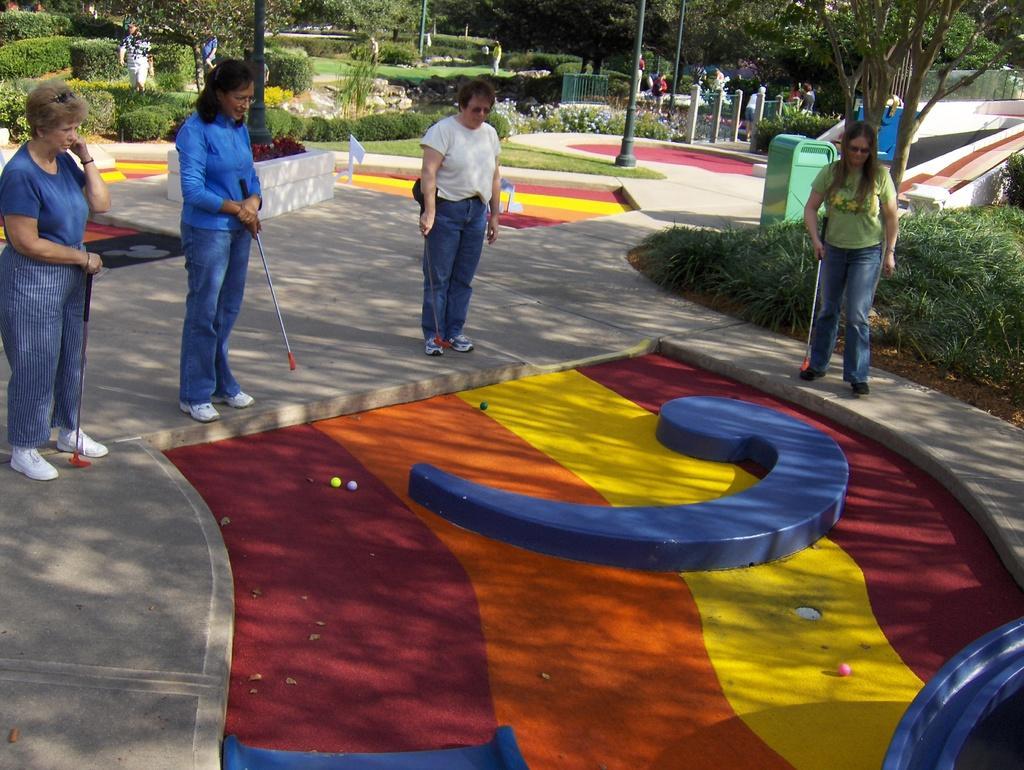In one or two sentences, can you explain what this image depicts? This is a golf area with balls. These people are holding golf bats. Background there are trees, people, plants and poles. 